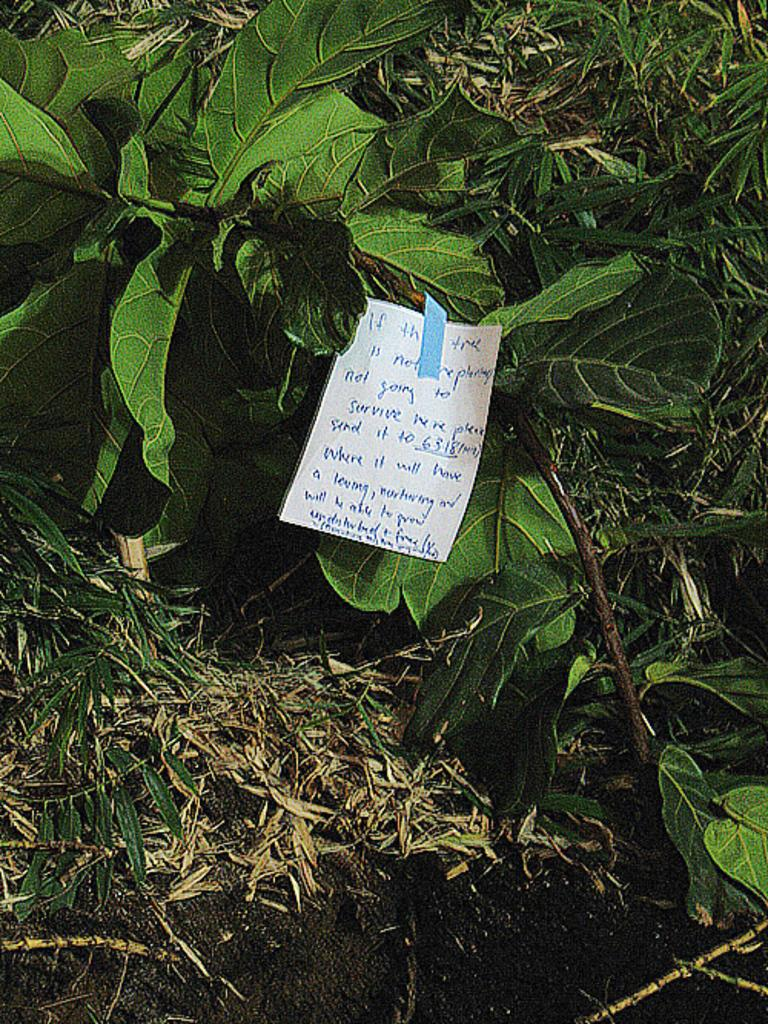What is written on the paper in the image? The image contains a paper with text written on it, but the specific content cannot be determined from the image. What type of vegetation is visible in the image? There are leaves and grass visible in the image. What time of day is it in the image? The time of day cannot be determined from the image, as there are no clues or indicators present. 